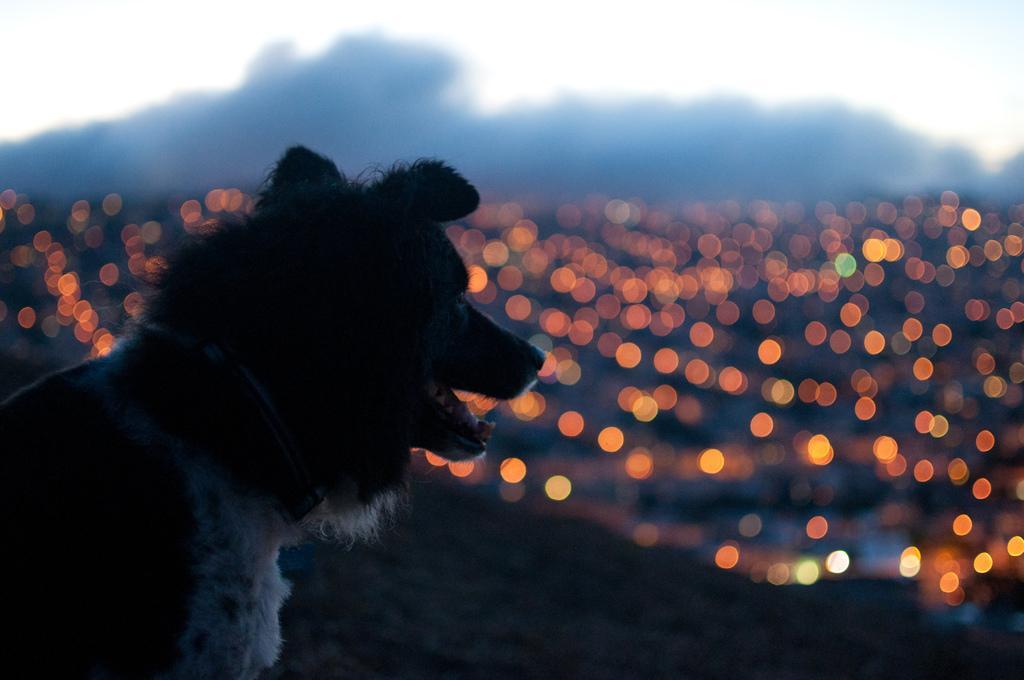In one or two sentences, can you explain what this image depicts? This image consists of a dog. In the background, we can see the light. The background is blurred. 